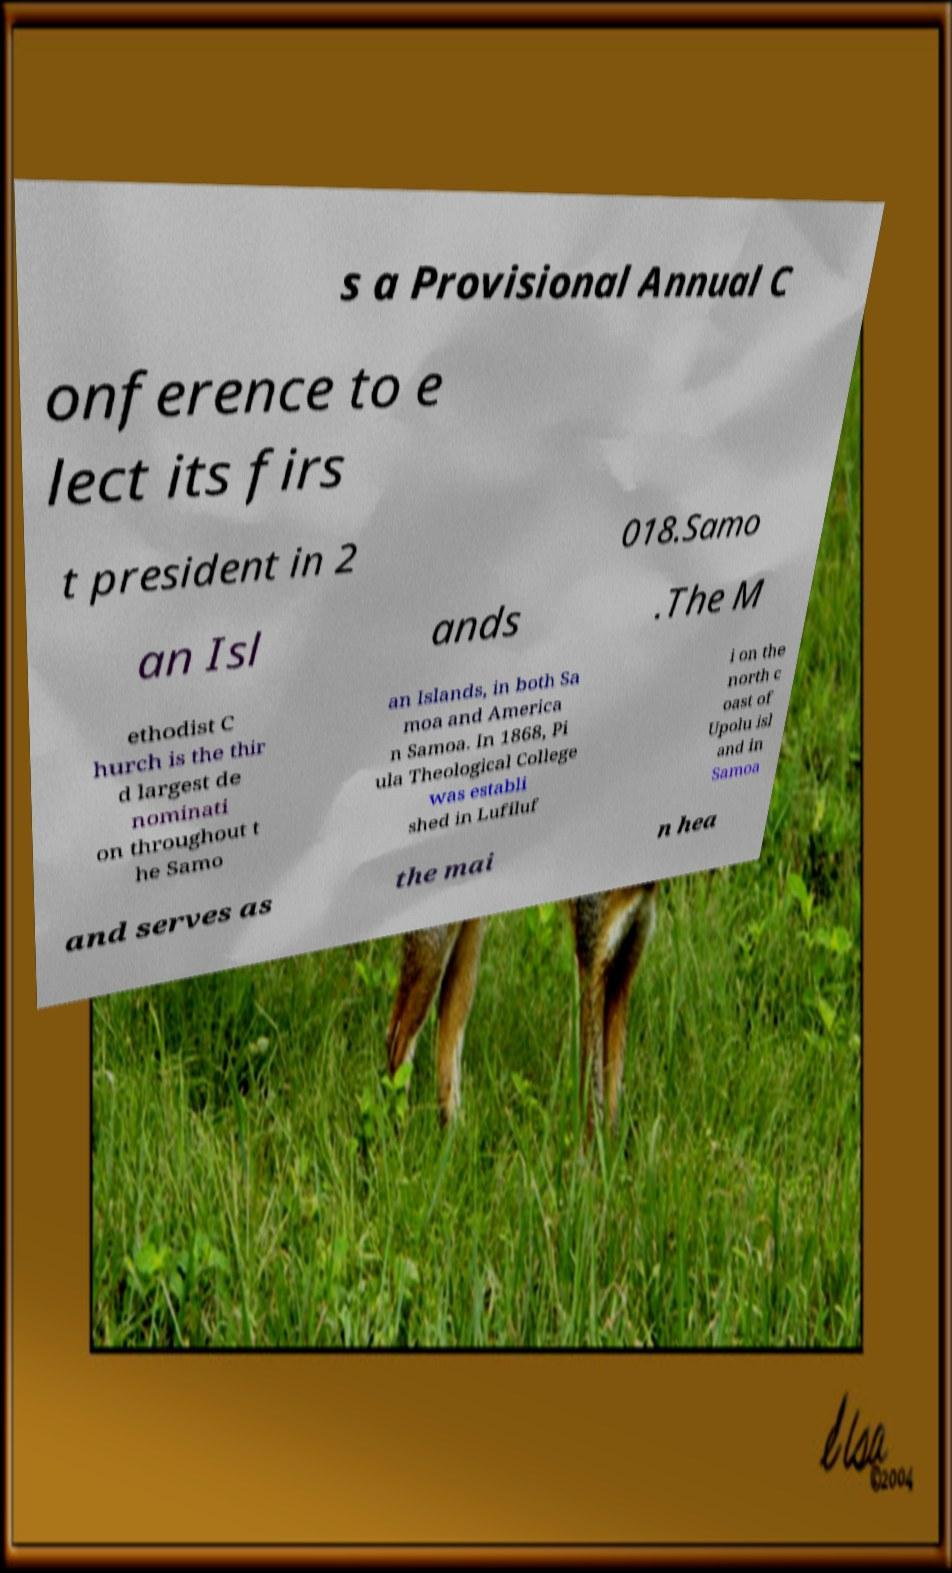Could you assist in decoding the text presented in this image and type it out clearly? s a Provisional Annual C onference to e lect its firs t president in 2 018.Samo an Isl ands .The M ethodist C hurch is the thir d largest de nominati on throughout t he Samo an Islands, in both Sa moa and America n Samoa. In 1868, Pi ula Theological College was establi shed in Lufiluf i on the north c oast of Upolu isl and in Samoa and serves as the mai n hea 